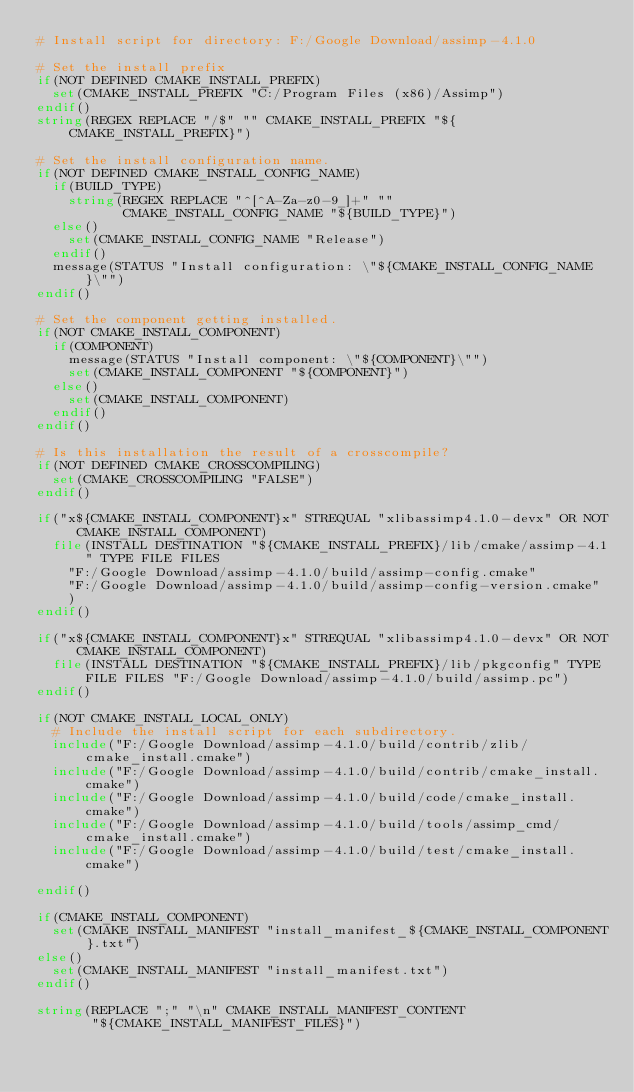<code> <loc_0><loc_0><loc_500><loc_500><_CMake_># Install script for directory: F:/Google Download/assimp-4.1.0

# Set the install prefix
if(NOT DEFINED CMAKE_INSTALL_PREFIX)
  set(CMAKE_INSTALL_PREFIX "C:/Program Files (x86)/Assimp")
endif()
string(REGEX REPLACE "/$" "" CMAKE_INSTALL_PREFIX "${CMAKE_INSTALL_PREFIX}")

# Set the install configuration name.
if(NOT DEFINED CMAKE_INSTALL_CONFIG_NAME)
  if(BUILD_TYPE)
    string(REGEX REPLACE "^[^A-Za-z0-9_]+" ""
           CMAKE_INSTALL_CONFIG_NAME "${BUILD_TYPE}")
  else()
    set(CMAKE_INSTALL_CONFIG_NAME "Release")
  endif()
  message(STATUS "Install configuration: \"${CMAKE_INSTALL_CONFIG_NAME}\"")
endif()

# Set the component getting installed.
if(NOT CMAKE_INSTALL_COMPONENT)
  if(COMPONENT)
    message(STATUS "Install component: \"${COMPONENT}\"")
    set(CMAKE_INSTALL_COMPONENT "${COMPONENT}")
  else()
    set(CMAKE_INSTALL_COMPONENT)
  endif()
endif()

# Is this installation the result of a crosscompile?
if(NOT DEFINED CMAKE_CROSSCOMPILING)
  set(CMAKE_CROSSCOMPILING "FALSE")
endif()

if("x${CMAKE_INSTALL_COMPONENT}x" STREQUAL "xlibassimp4.1.0-devx" OR NOT CMAKE_INSTALL_COMPONENT)
  file(INSTALL DESTINATION "${CMAKE_INSTALL_PREFIX}/lib/cmake/assimp-4.1" TYPE FILE FILES
    "F:/Google Download/assimp-4.1.0/build/assimp-config.cmake"
    "F:/Google Download/assimp-4.1.0/build/assimp-config-version.cmake"
    )
endif()

if("x${CMAKE_INSTALL_COMPONENT}x" STREQUAL "xlibassimp4.1.0-devx" OR NOT CMAKE_INSTALL_COMPONENT)
  file(INSTALL DESTINATION "${CMAKE_INSTALL_PREFIX}/lib/pkgconfig" TYPE FILE FILES "F:/Google Download/assimp-4.1.0/build/assimp.pc")
endif()

if(NOT CMAKE_INSTALL_LOCAL_ONLY)
  # Include the install script for each subdirectory.
  include("F:/Google Download/assimp-4.1.0/build/contrib/zlib/cmake_install.cmake")
  include("F:/Google Download/assimp-4.1.0/build/contrib/cmake_install.cmake")
  include("F:/Google Download/assimp-4.1.0/build/code/cmake_install.cmake")
  include("F:/Google Download/assimp-4.1.0/build/tools/assimp_cmd/cmake_install.cmake")
  include("F:/Google Download/assimp-4.1.0/build/test/cmake_install.cmake")

endif()

if(CMAKE_INSTALL_COMPONENT)
  set(CMAKE_INSTALL_MANIFEST "install_manifest_${CMAKE_INSTALL_COMPONENT}.txt")
else()
  set(CMAKE_INSTALL_MANIFEST "install_manifest.txt")
endif()

string(REPLACE ";" "\n" CMAKE_INSTALL_MANIFEST_CONTENT
       "${CMAKE_INSTALL_MANIFEST_FILES}")</code> 